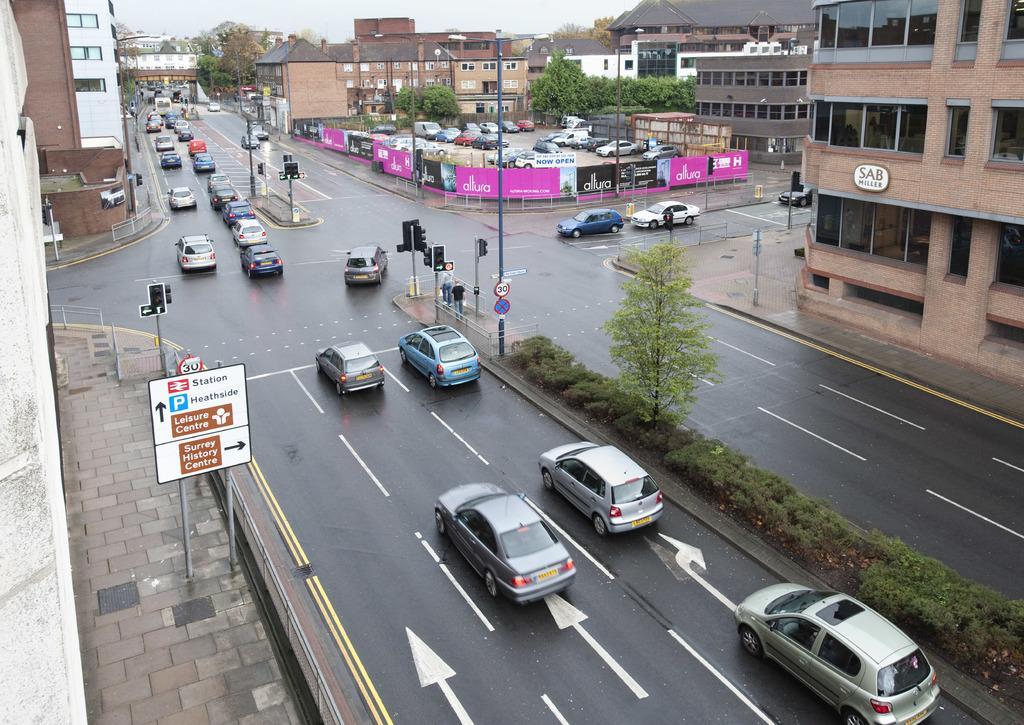Describe this image in one or two sentences. There are vehicles on the road, there are trees and buildings. 